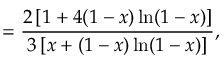Convert formula to latex. <formula><loc_0><loc_0><loc_500><loc_500>= \frac { 2 \left [ 1 + 4 ( 1 - x ) \ln ( 1 - x ) \right ] } { 3 \left [ x + ( 1 - x ) \ln ( 1 - x ) \right ] } ,</formula> 